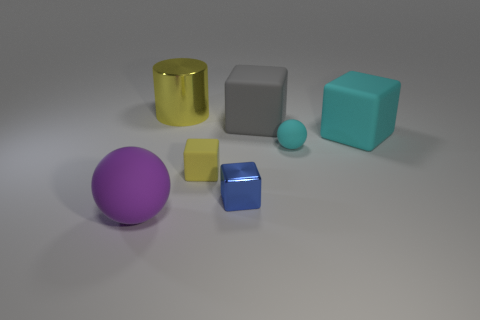There is a cube that is the same color as the tiny sphere; what size is it? The cube sharing the same color as the tiny sphere is medium-sized in comparison with the other objects in the image. 